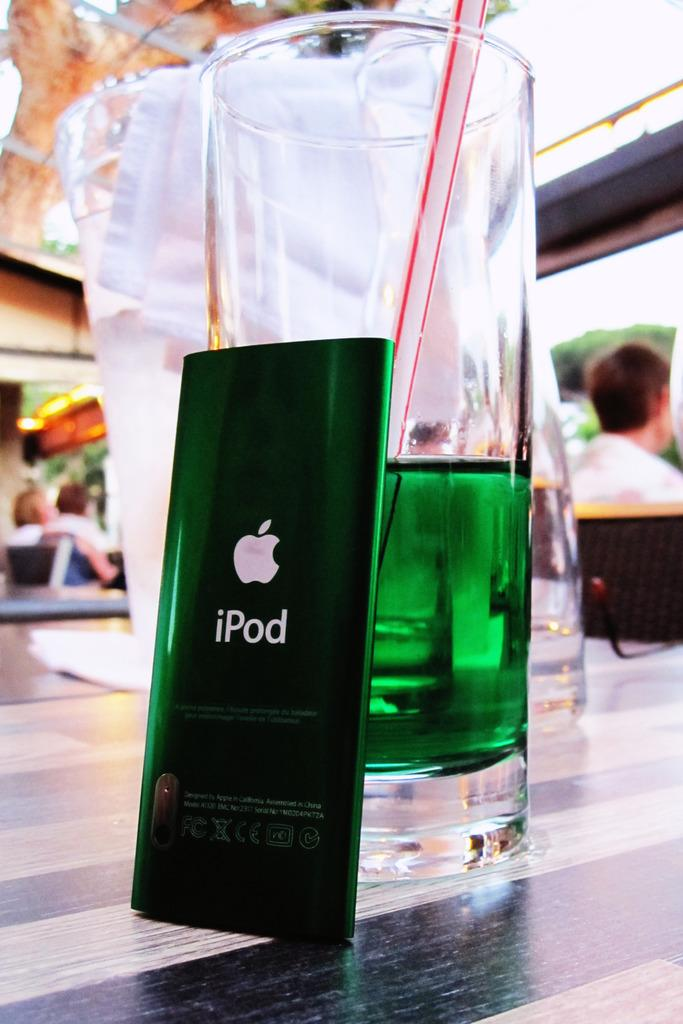<image>
Describe the image concisely. A green iPod is resting face down against a glass. 